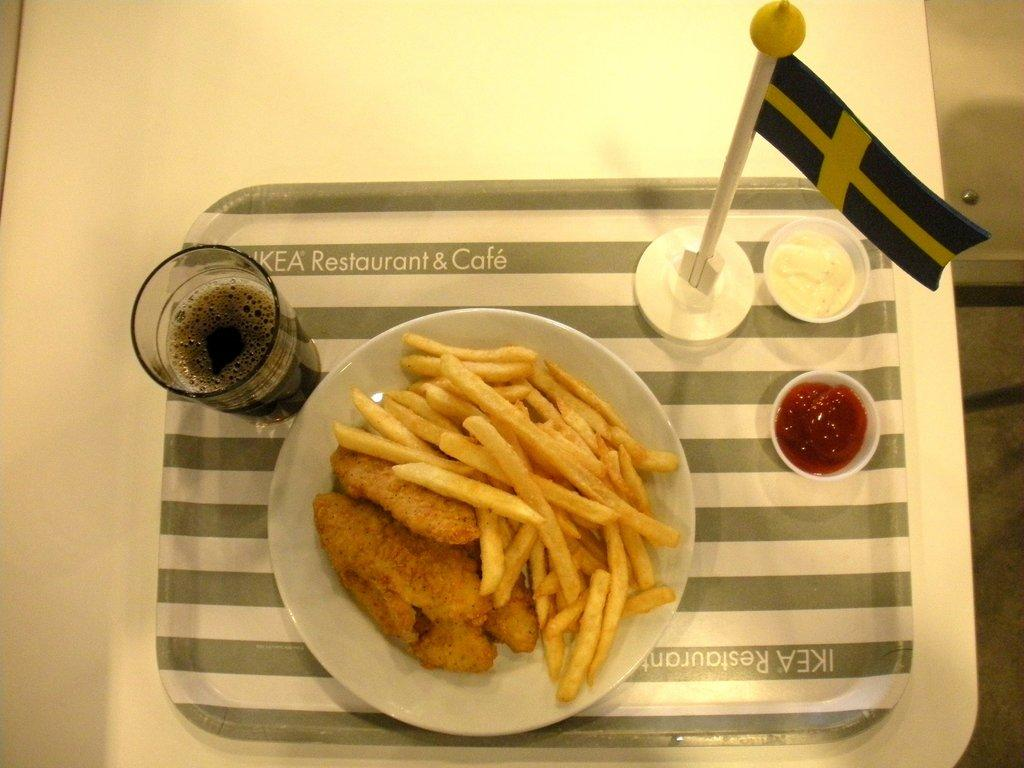What is the main piece of furniture in the image? There is a table in the image. What is placed on the table? A tray, a plate, a glass, a flag, and two bowls are placed on the table. What is on the plate? There are fries and another food item on the plate. What is in the bowls? The contents of the bowls are not specified in the facts. What type of rhythm can be heard in the image? There is no audible rhythm present in the image, as it is a still photograph. 